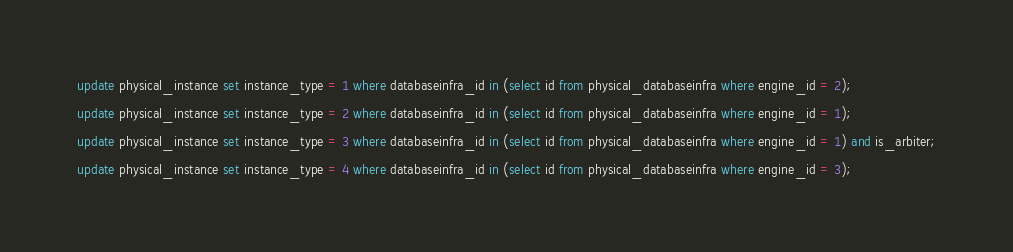Convert code to text. <code><loc_0><loc_0><loc_500><loc_500><_SQL_>update physical_instance set instance_type = 1 where databaseinfra_id in (select id from physical_databaseinfra where engine_id = 2);

update physical_instance set instance_type = 2 where databaseinfra_id in (select id from physical_databaseinfra where engine_id = 1);

update physical_instance set instance_type = 3 where databaseinfra_id in (select id from physical_databaseinfra where engine_id = 1) and is_arbiter;

update physical_instance set instance_type = 4 where databaseinfra_id in (select id from physical_databaseinfra where engine_id = 3);

</code> 